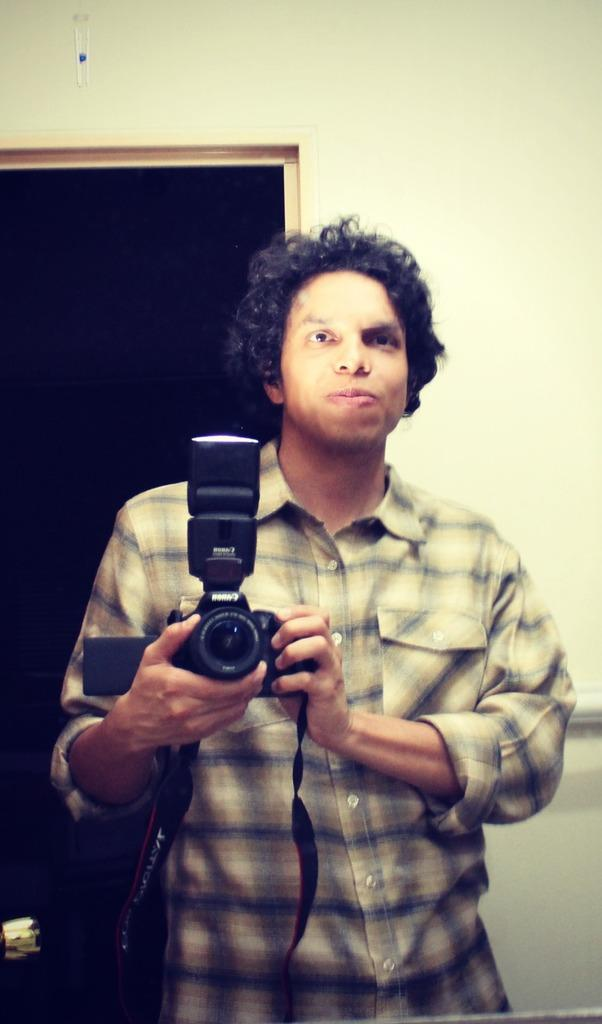Who is present in the image? There is a man in the image. What is the man holding in his hand? The man is holding a camera in his hand. What type of badge is the man wearing in the image? There is no badge visible in the image. What type of war is depicted in the image? There is no war depicted in the image; it only features a man holding a camera. 